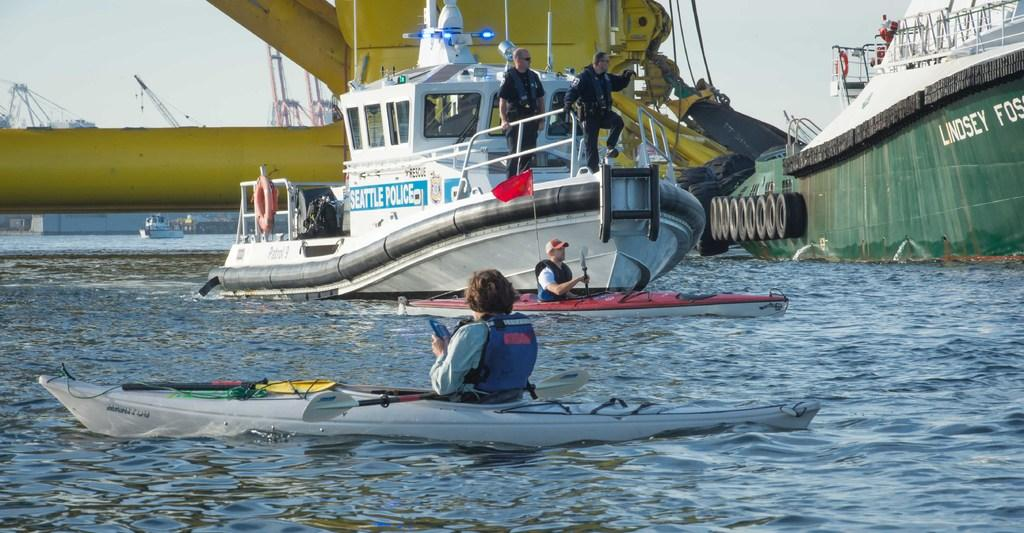What are the people in the image doing? The people in the image are in the boats and ships. Where are the boats and ships located? The boats and ships are on the water surface. What can be seen in the image besides the boats and ships? There is a red color flag, a tube connected to a ship, and other objects visible in the image. What is visible in the background of the image? The sky is visible in the image. What type of celery is being used as a prop in the image? There is no celery present in the image. Is there a key visible in the image? No, there is no key visible in the image. 